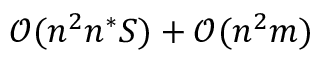Convert formula to latex. <formula><loc_0><loc_0><loc_500><loc_500>\mathcal { O } ( n ^ { 2 } n ^ { * } S ) + \mathcal { O } ( n ^ { 2 } m )</formula> 